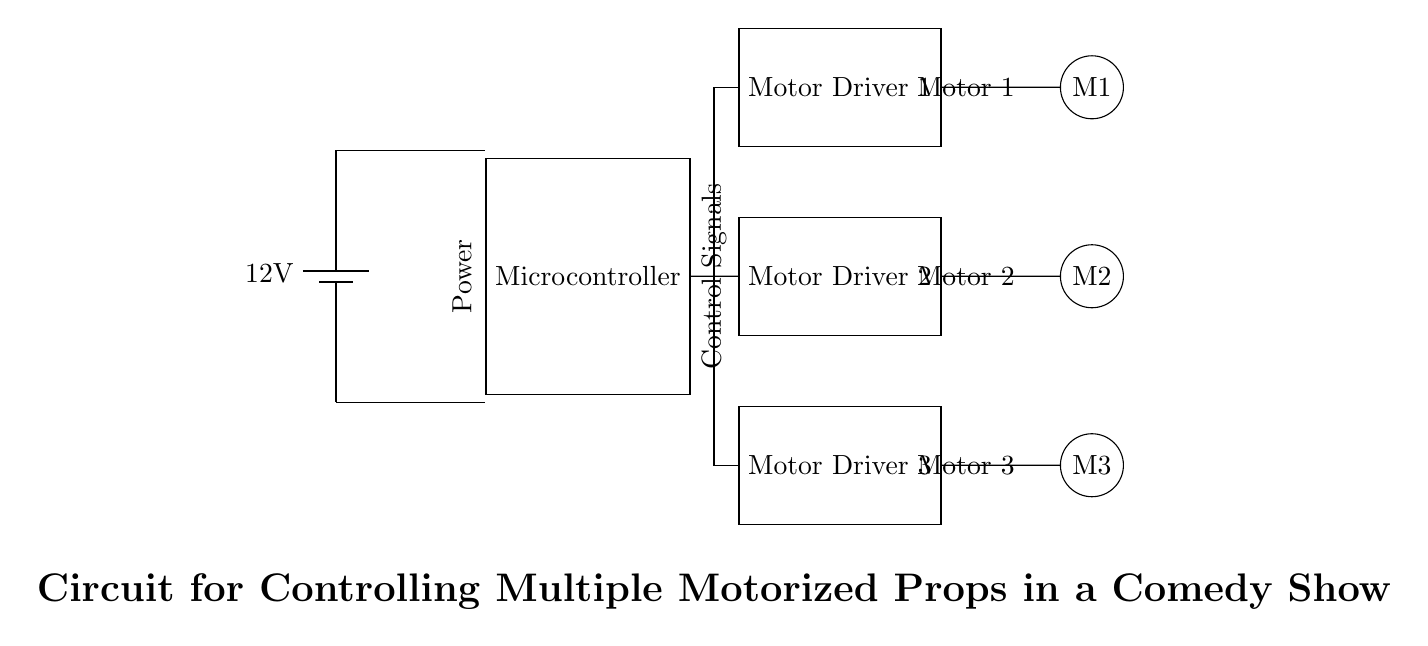What is the voltage of this circuit? The voltage is 12 volts, as indicated by the battery symbol at the top left of the diagram.
Answer: 12 volts How many motor drivers are present in the circuit? There are three motor drivers in the circuit, labeled as Motor Driver 1, Motor Driver 2, and Motor Driver 3.
Answer: Three What device controls the motors? The microcontroller is the device that provides control signals to the motor drivers, controlling their operation.
Answer: Microcontroller What is the purpose of the motor drivers in this circuit? The motor drivers serve to amplify the control signals from the microcontroller so that they can drive the motors.
Answer: Amplification Which motor is energized first according to the layout? According to the layout, Motor 1 is positioned at the top, suggesting that signals from the motor driver 1 come first in a typical sequential operation.
Answer: Motor 1 What type of power supply is used in this circuit? The circuit uses a direct current power supply, indicated by the battery symbol, which is a common type for these applications.
Answer: Direct current How is the microcontroller powered in this circuit? The microcontroller is powered by connecting it directly to the positive and negative terminals of the battery, ensuring it receives necessary power.
Answer: Direct connection 